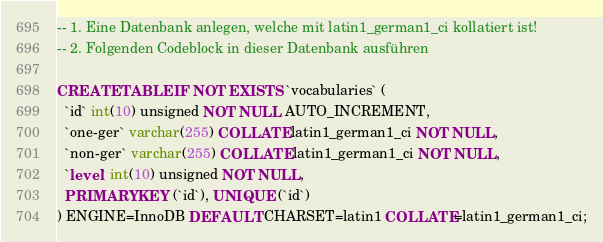<code> <loc_0><loc_0><loc_500><loc_500><_SQL_>-- 1. Eine Datenbank anlegen, welche mit latin1_german1_ci kollatiert ist!
-- 2. Folgenden Codeblock in dieser Datenbank ausführen

CREATE TABLE IF NOT EXISTS `vocabularies` (
  `id` int(10) unsigned NOT NULL AUTO_INCREMENT,
  `one-ger` varchar(255) COLLATE latin1_german1_ci NOT NULL,
  `non-ger` varchar(255) COLLATE latin1_german1_ci NOT NULL,
  `level` int(10) unsigned NOT NULL,
  PRIMARY KEY (`id`), UNIQUE (`id`)
) ENGINE=InnoDB DEFAULT CHARSET=latin1 COLLATE=latin1_german1_ci;
</code> 